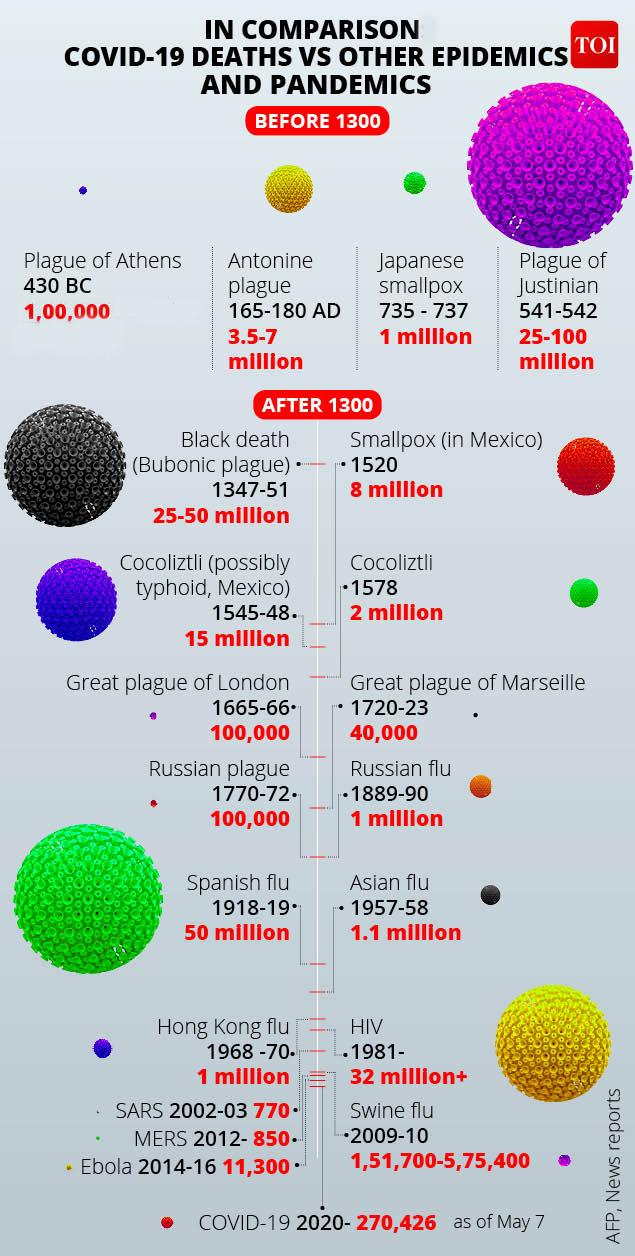Mention a couple of crucial points in this snapshot. As of May 7, 2020, the number of COVID-19 deaths worldwide has reached 270,426. The Russian flu pandemic, which resulted in the death of approximately 1 million people, occurred between 1889 and 1890. In 1520, the small pox disease caused an estimated 8 million deaths in Mexico. The Antonine plague occurred in the years 165-180 AD. During the 1957-58 influenza pandemic, also known as Asian flu, an estimated 1.1 million people were killed worldwide. 